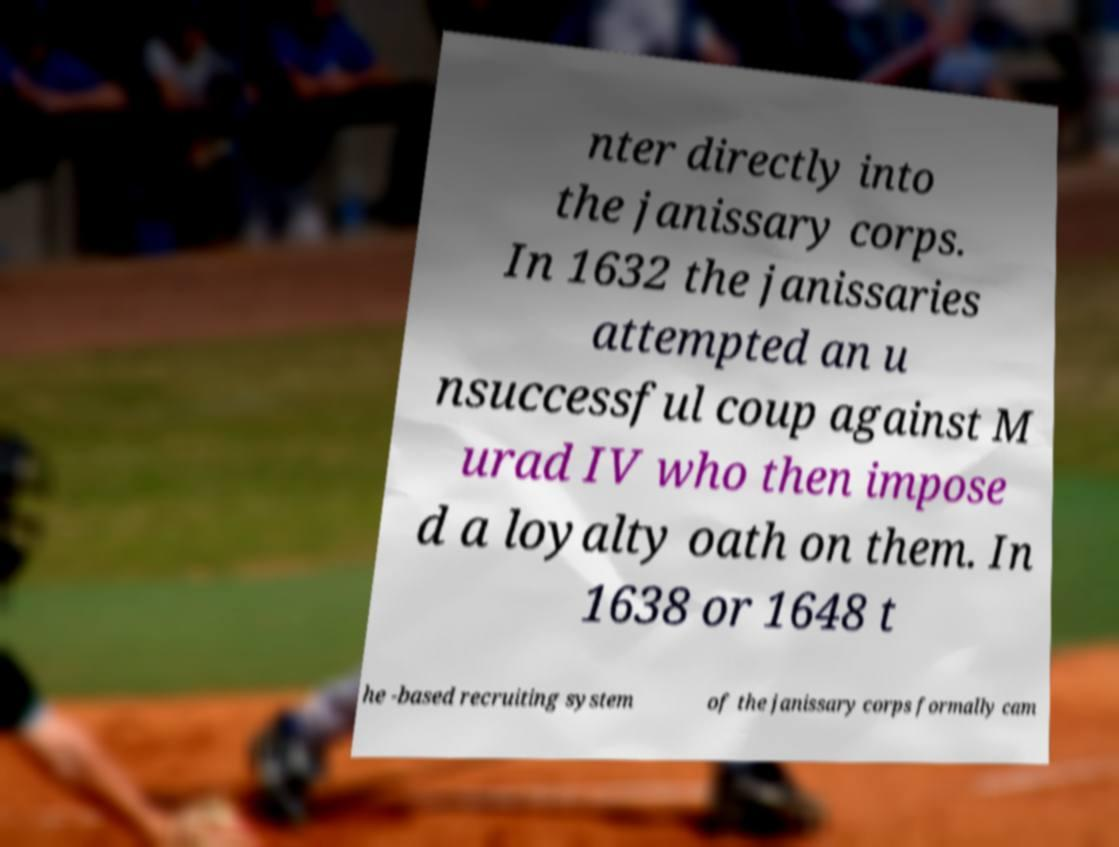There's text embedded in this image that I need extracted. Can you transcribe it verbatim? nter directly into the janissary corps. In 1632 the janissaries attempted an u nsuccessful coup against M urad IV who then impose d a loyalty oath on them. In 1638 or 1648 t he -based recruiting system of the janissary corps formally cam 